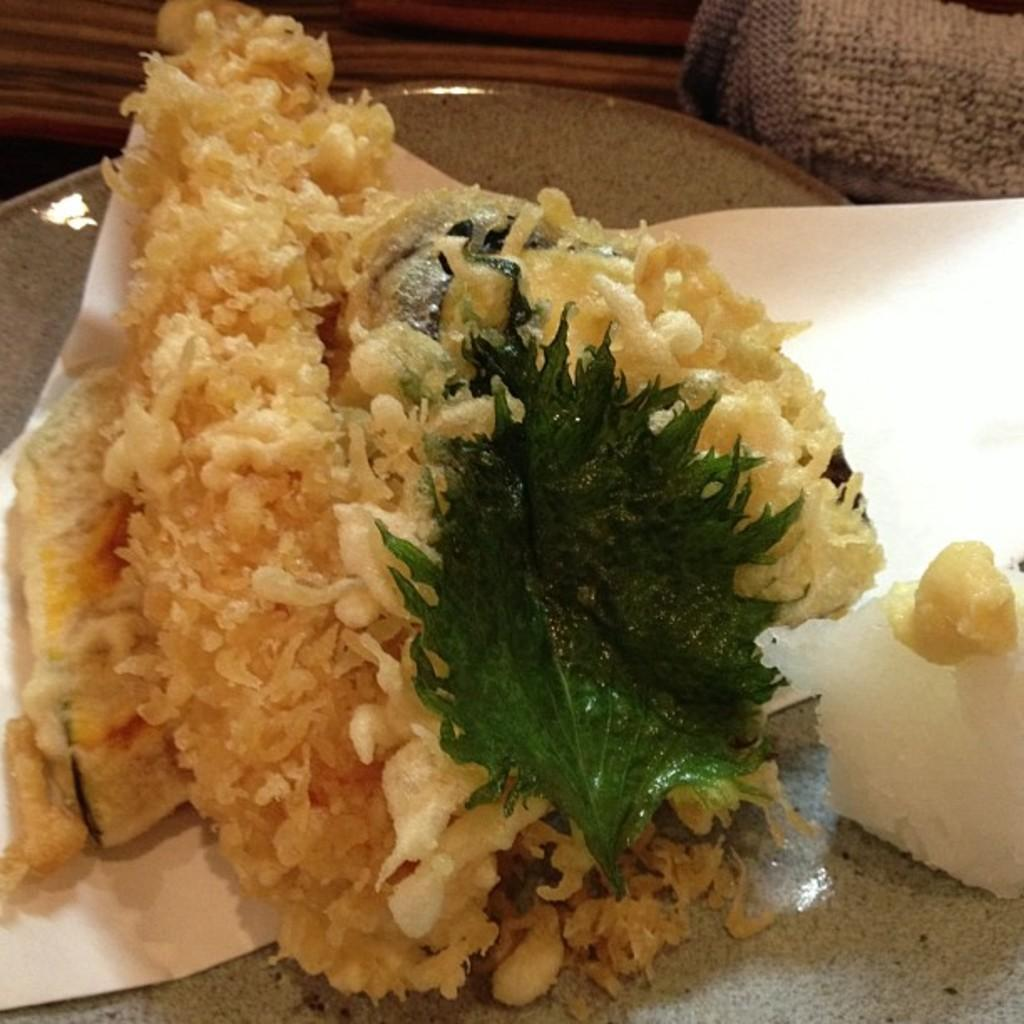What types of items can be seen in the image? There are food items, paper, and a leaf in the image. Can you describe the unspecified objects in the image? Unfortunately, the facts provided do not give any details about the unspecified objects. What might be the purpose of the paper in the image? The purpose of the paper in the image is not clear from the provided facts. How many feet can be seen in the image? There are no feet present in the image. What type of nest is visible in the image? There is no nest present in the image. 